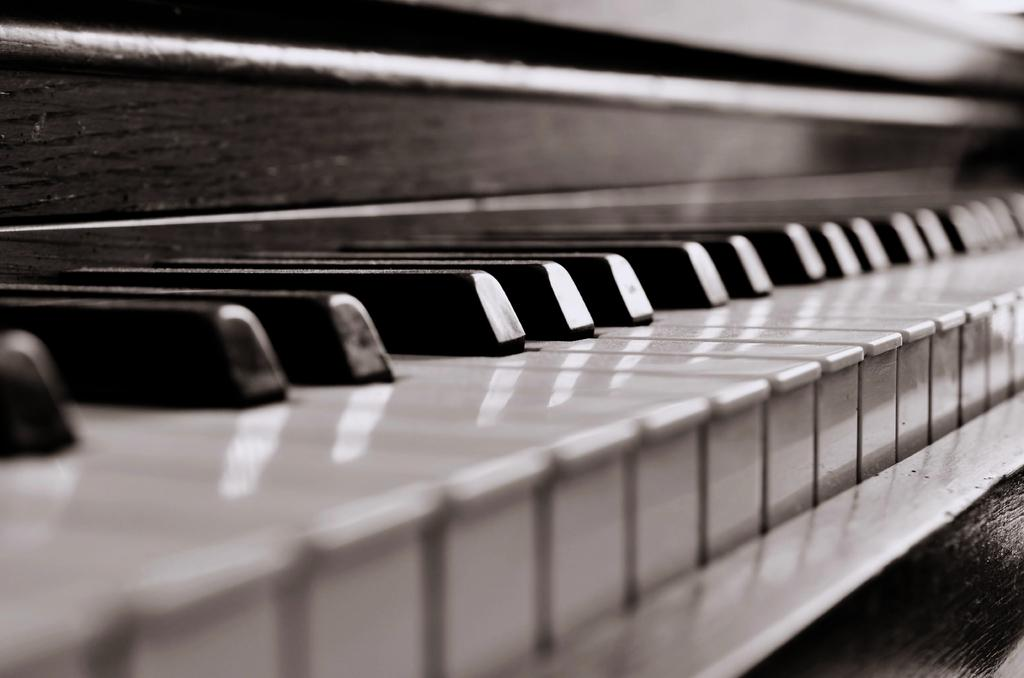What musical instrument is present in the image? There is a piano in the image. What are the two types of keys on the piano? The piano has white keys and black keys. What type of plant is growing on the piano in the image? There is no plant growing on the piano in the image. What is the name of the person who played the piano during their voyage? The image does not provide information about a person playing the piano or any voyage, so we cannot determine the name of the person. 